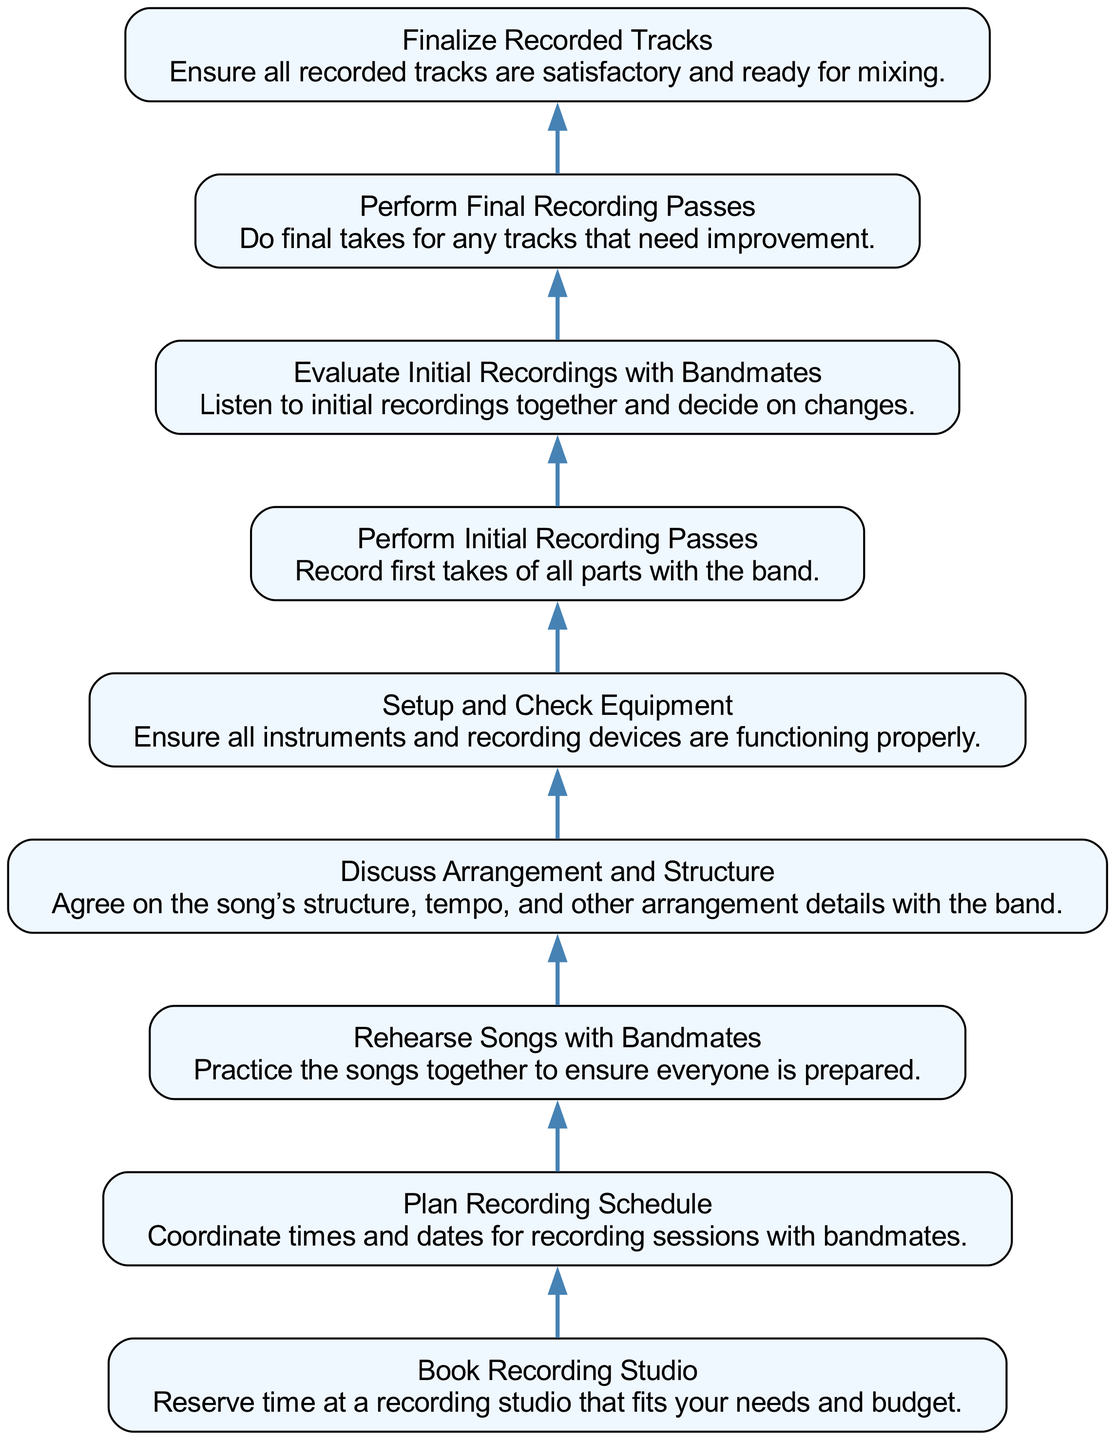What is the first step in the workflow? The diagram starts from the bottom with the node labeled "Book Recording Studio," which indicates that this is the first action needed in the recording session workflow.
Answer: Book Recording Studio How many total steps are in the workflow? By counting all nodes in the diagram, we can see there are nine steps, ranging from "Book Recording Studio" to "Finalize Recorded Tracks."
Answer: 9 Which node directly follows "Setup and Check Equipment"? The node that comes directly above "Setup and Check Equipment" is "Rehearse Songs with Bandmates," as the flow of the diagram proceeds upwards from the lower node to the next one.
Answer: Rehearse Songs with Bandmates What happens after "Evaluate Initial Recordings with Bandmates"? The next step following "Evaluate Initial Recordings with Bandmates" is "Perform Final Recording Passes," indicating that after evaluating, the focus shifts to improving the recording.
Answer: Perform Final Recording Passes Which two steps are directly before the "Finalize Recorded Tracks"? The steps "Perform Final Recording Passes" and "Evaluate Initial Recordings with Bandmates" are both immediately preceding the "Finalize Recorded Tracks," showing that final passes and evaluations are crucial before finalization.
Answer: Perform Final Recording Passes and Evaluate Initial Recordings with Bandmates What is the relationship between "Discuss Arrangement and Structure" and "Perform Initial Recording Passes"? "Discuss Arrangement and Structure" is positioned below "Perform Initial Recording Passes," indicating that arranging and structuring discussions precede the actual recording passes in the process.
Answer: Discuss Arrangement and Structure precedes Perform Initial Recording Passes What is the last step you must complete before moving to the mixing stage? The final step before moving on to mixing is "Finalize Recorded Tracks," indicating that all recordings need to be satisfactory before this transition.
Answer: Finalize Recorded Tracks How many edges are in the diagram? By counting the connections between nodes, we find there are eight edges, showing the flow from the first step to the final step.
Answer: 8 Which step comes after "Plan Recording Schedule"? After "Plan Recording Schedule," the next step is to "Book Recording Studio," indicating the scheduling leads to the reservation of studio time.
Answer: Book Recording Studio 